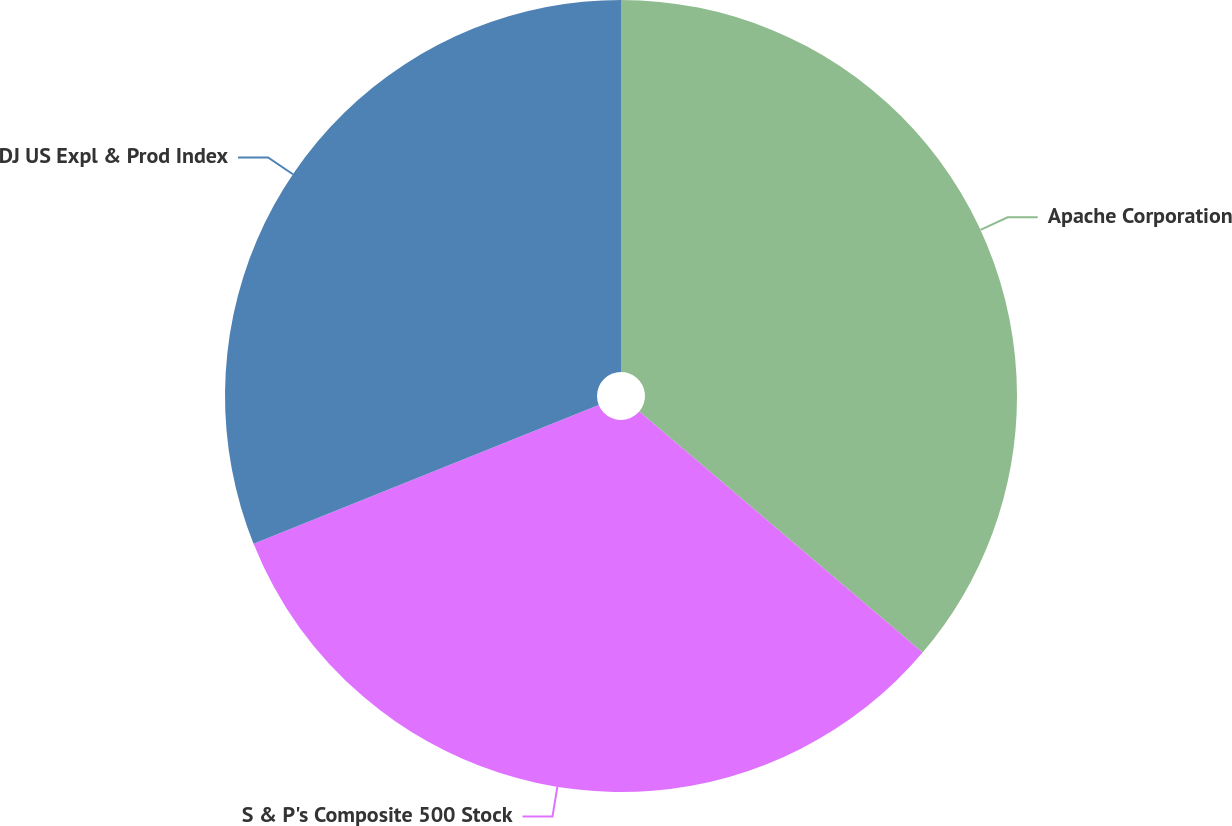Convert chart. <chart><loc_0><loc_0><loc_500><loc_500><pie_chart><fcel>Apache Corporation<fcel>S & P's Composite 500 Stock<fcel>DJ US Expl & Prod Index<nl><fcel>36.22%<fcel>32.7%<fcel>31.08%<nl></chart> 